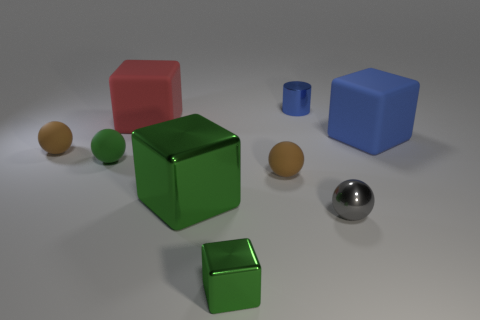There is a blue thing behind the blue object on the right side of the blue cylinder; how many large green metal cubes are in front of it? I see one large green metal cube positioned in front of the blue cylinder you’re referring to. It stands out distinctly against the neutral background. 